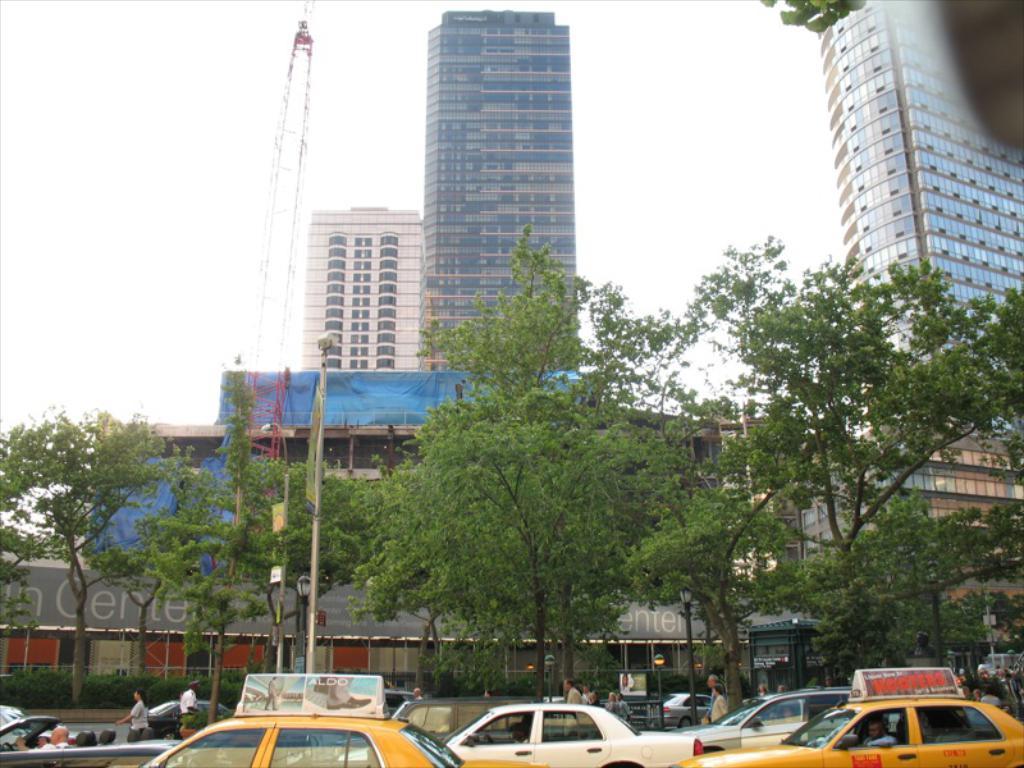What does it say on the taxi sign?
Keep it short and to the point. Aldo. 